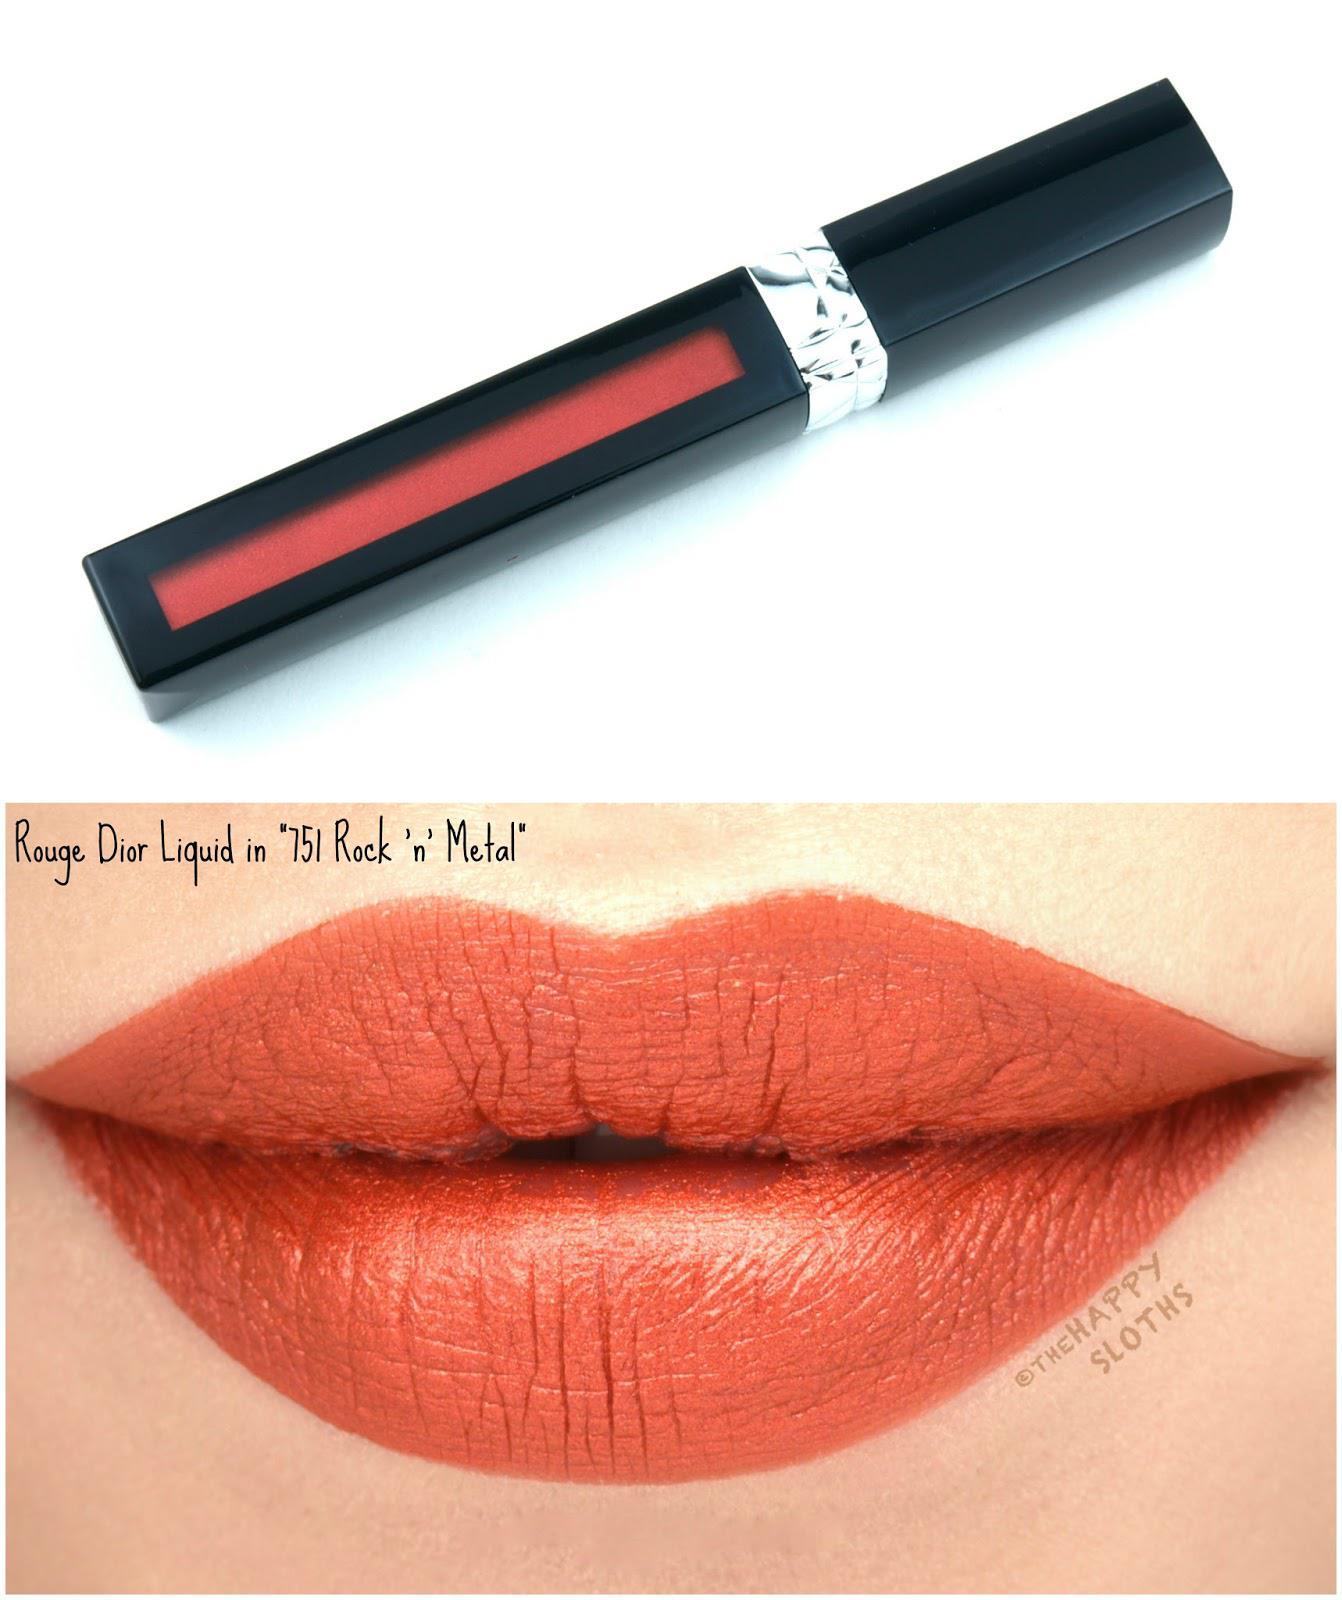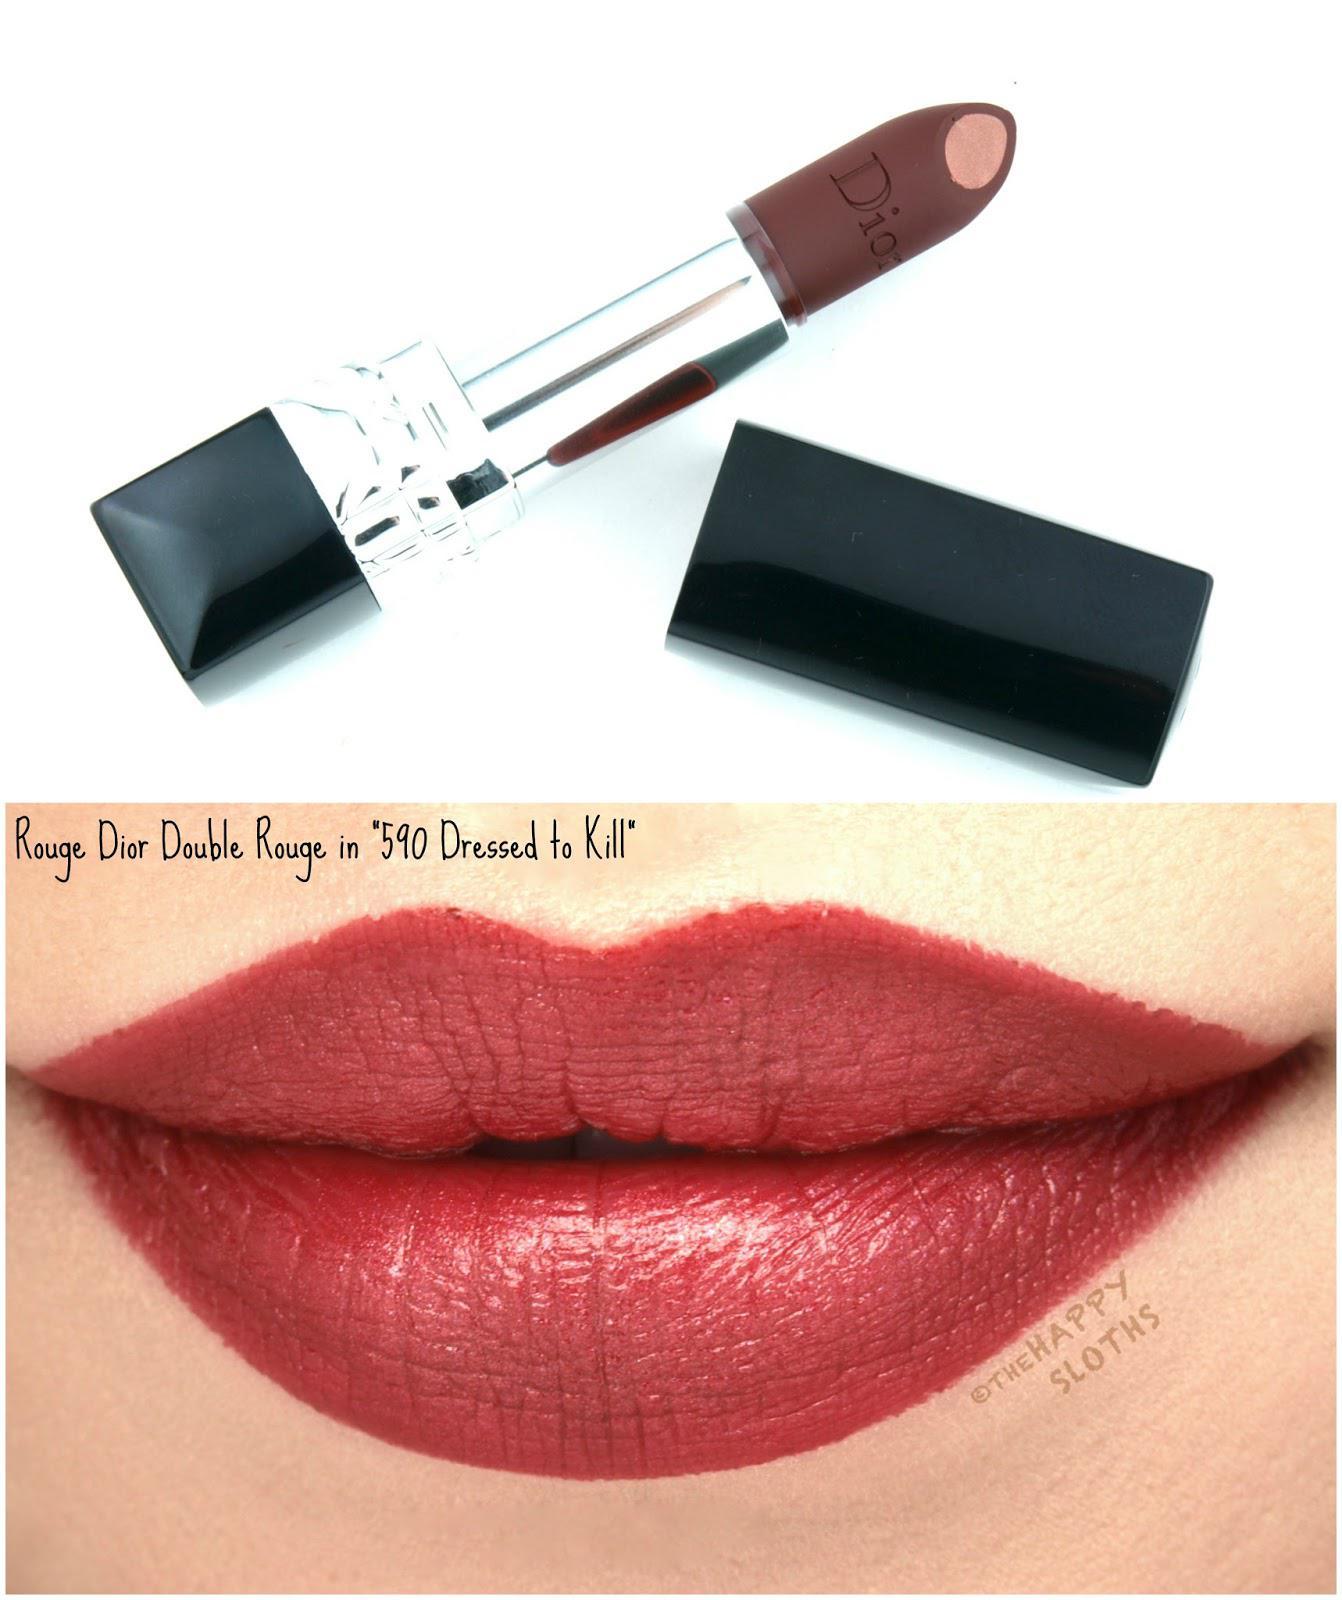The first image is the image on the left, the second image is the image on the right. Analyze the images presented: Is the assertion "The lip stick in the right image is uncapped." valid? Answer yes or no. Yes. The first image is the image on the left, the second image is the image on the right. Assess this claim about the two images: "The left image contains a lidded slender lip makeup over a pair of lips, while the right image shows an uncapped tube lipstick over a pair of lips.". Correct or not? Answer yes or no. Yes. 